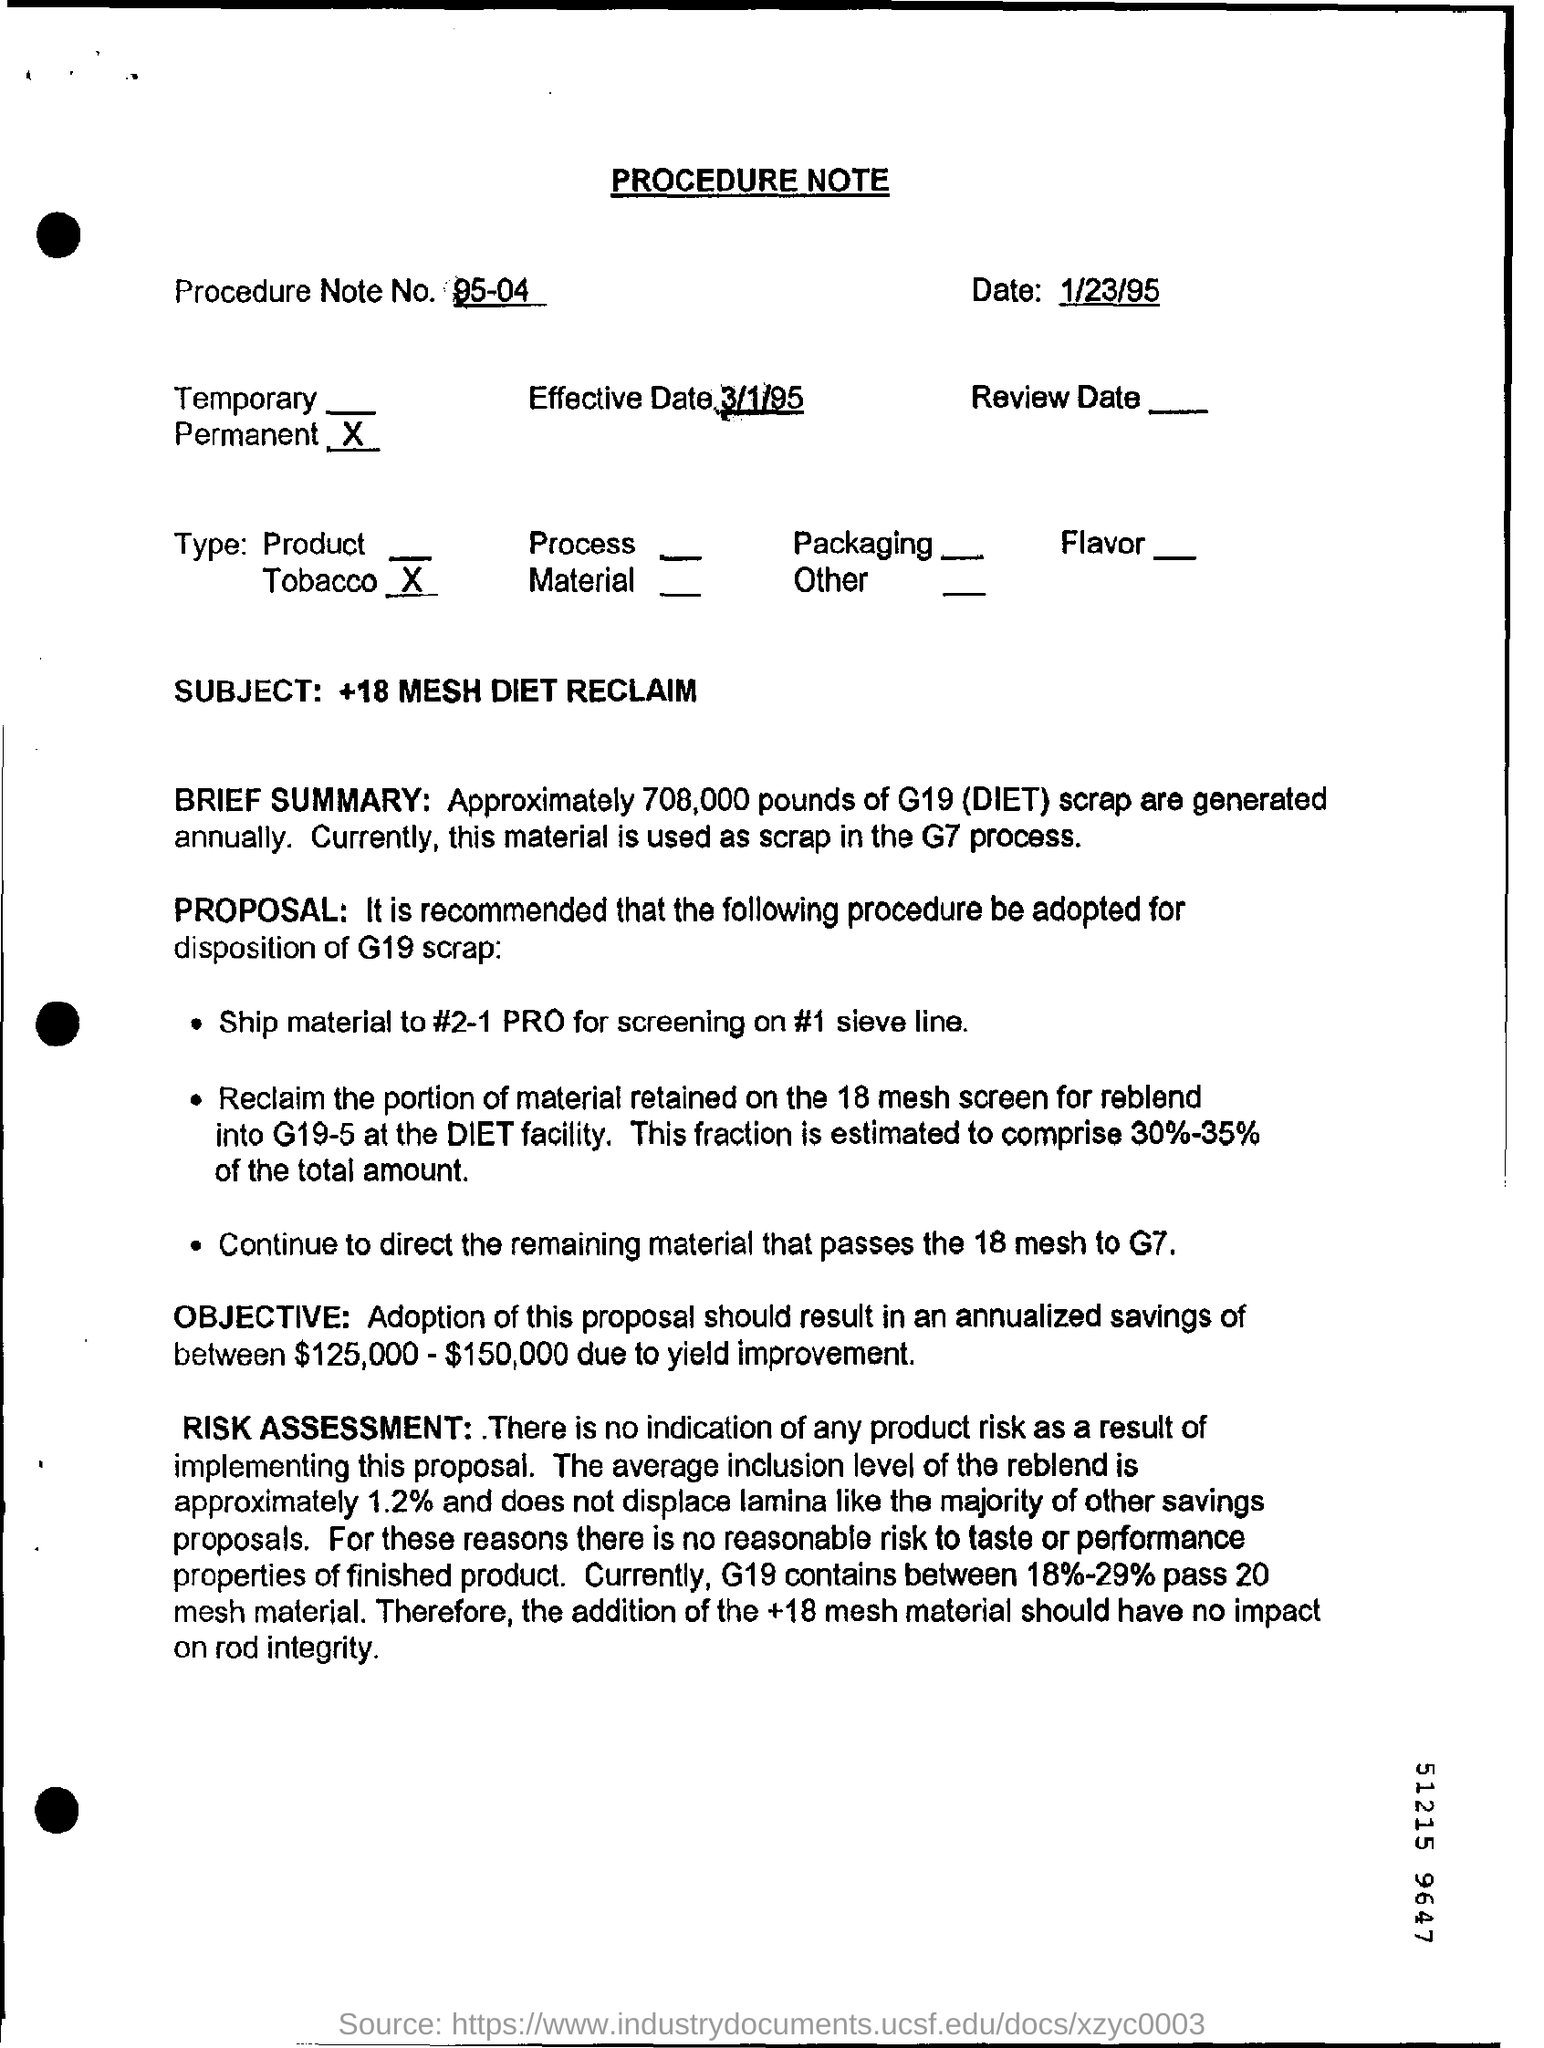What kind of document is this?
Offer a very short reply. PROCEDURE NOTE. What is the Effective Date mentioned in this document?
Your answer should be very brief. 3/1/95. What is the Procedure Note No of the given document?
Offer a terse response. 95-04. What is the subject mentioned in the procedure note?
Provide a succinct answer. +18 MESH DIET RECLAIM. How many pounds of G19(DIET)scrap are generated annually?
Your answer should be compact. Approximately 708,000 pounds. 